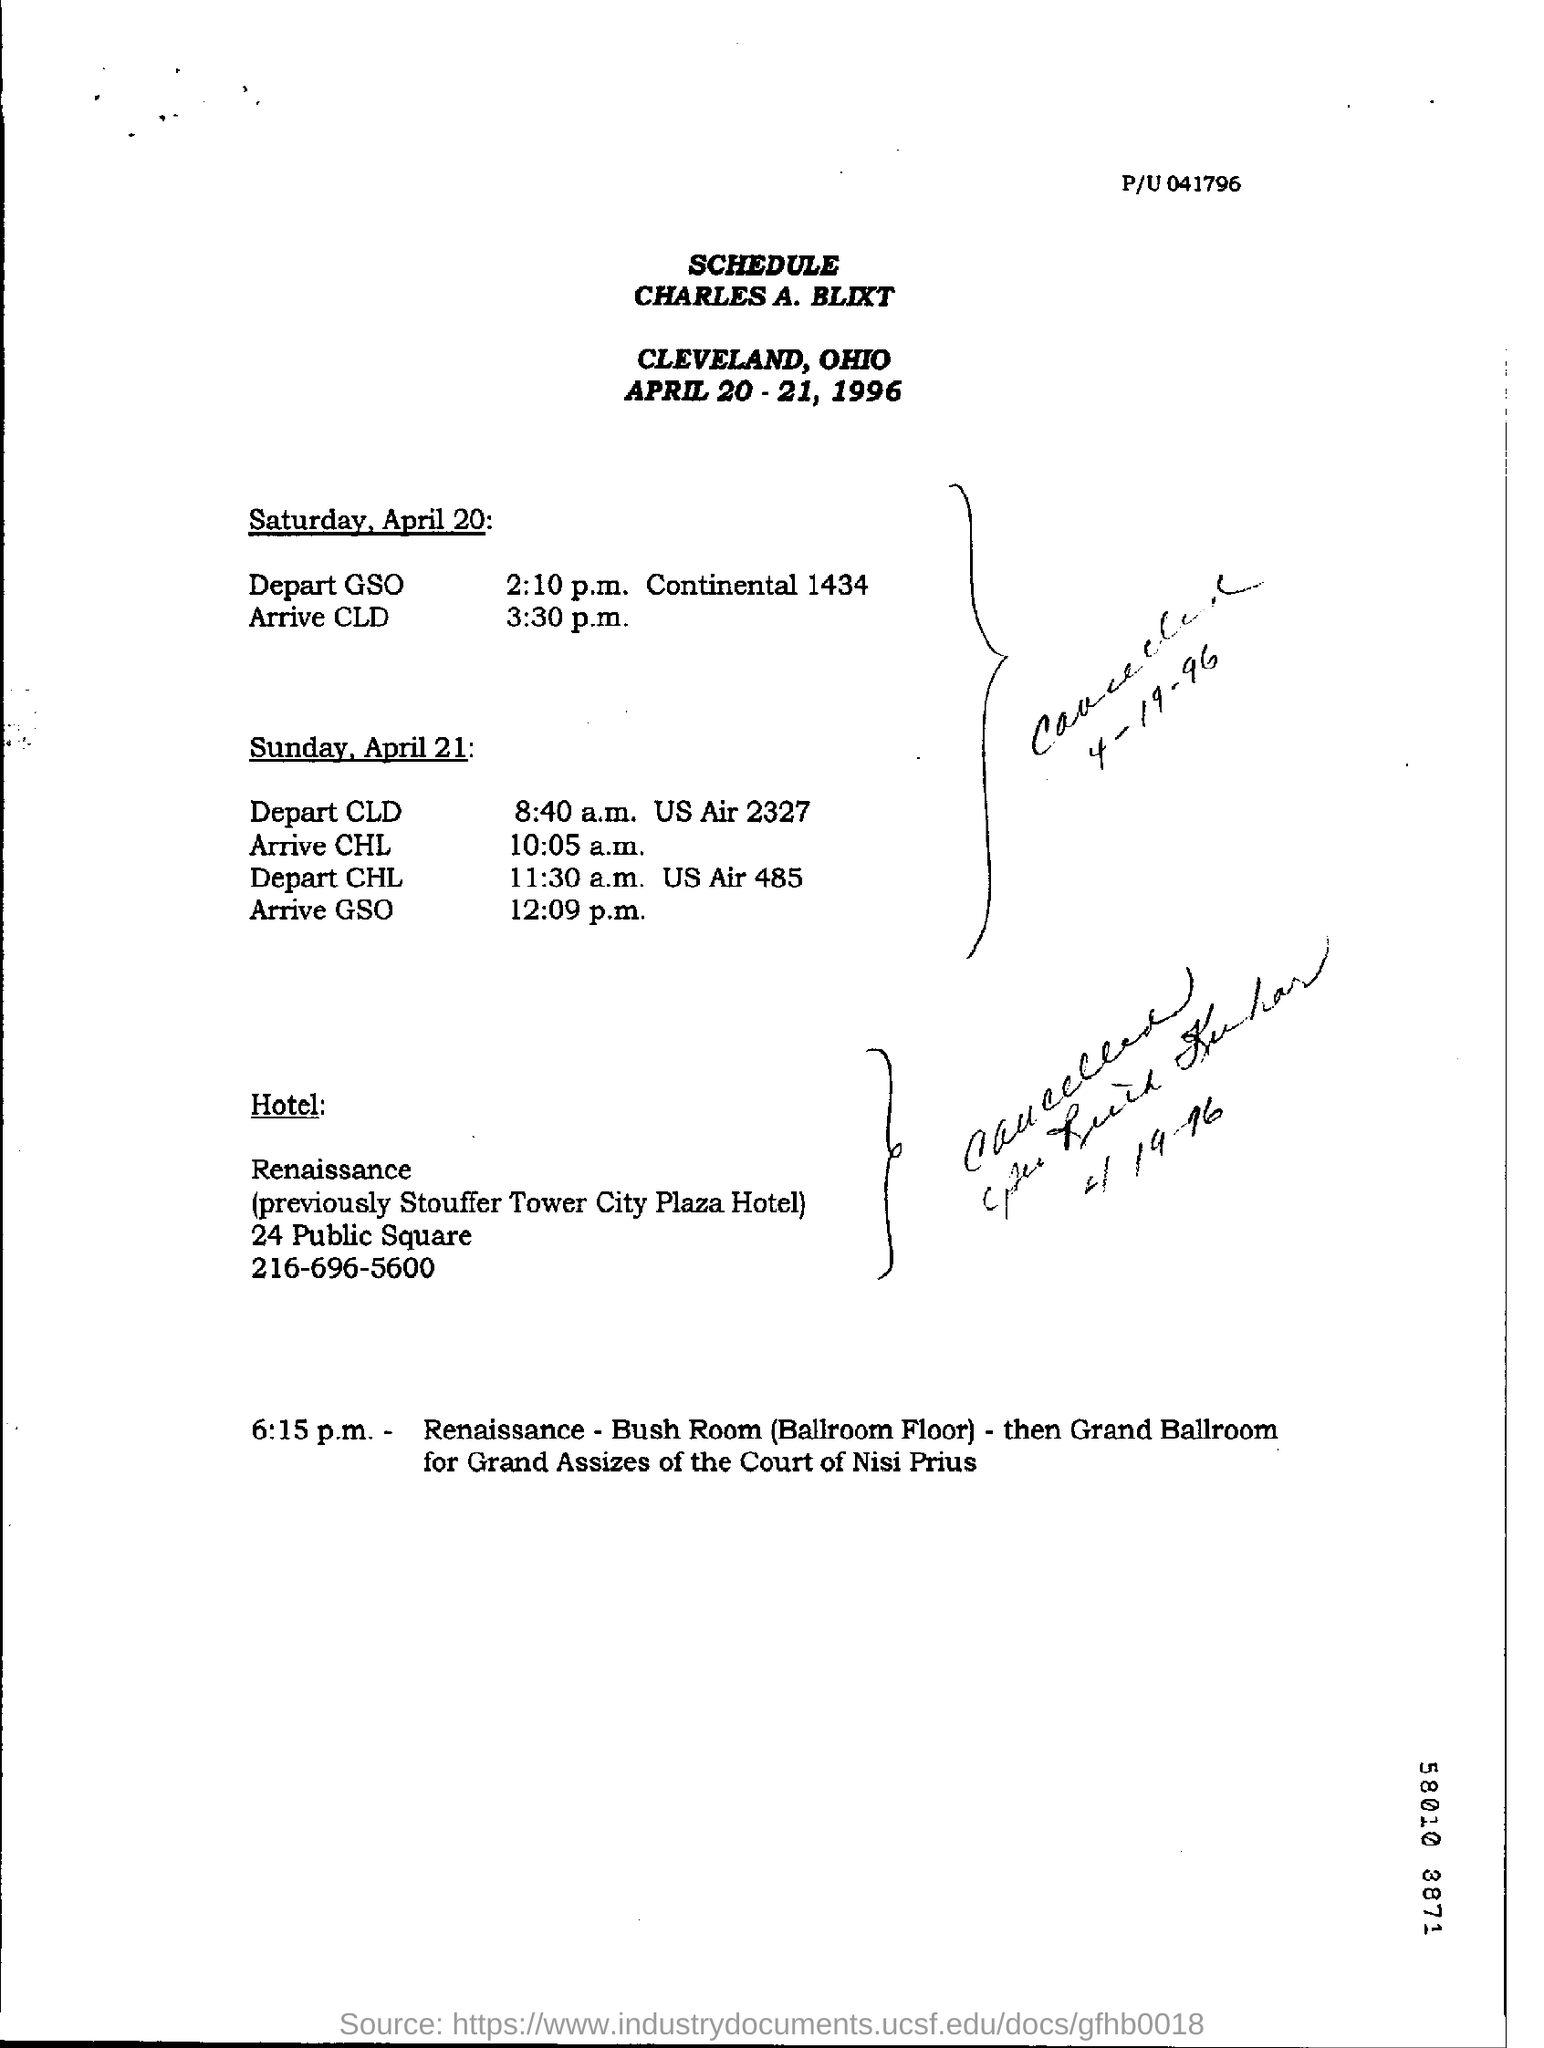Highlight a few significant elements in this photo. April 20th is a Saturday. Prior to its current name, Renaissance Stouffer Tower City Plaza Hotel was known as Stouffer Tower City Plaza Hotel. On April 21st, it is a Sunday. 